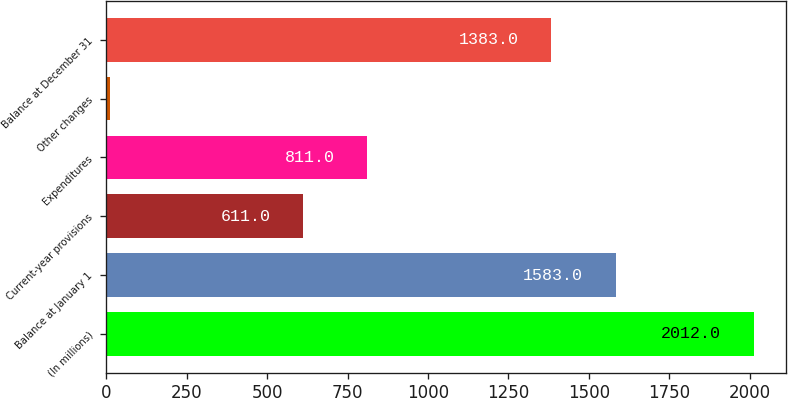Convert chart. <chart><loc_0><loc_0><loc_500><loc_500><bar_chart><fcel>(In millions)<fcel>Balance at January 1<fcel>Current-year provisions<fcel>Expenditures<fcel>Other changes<fcel>Balance at December 31<nl><fcel>2012<fcel>1583<fcel>611<fcel>811<fcel>12<fcel>1383<nl></chart> 